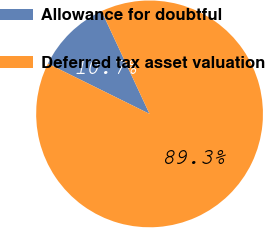Convert chart to OTSL. <chart><loc_0><loc_0><loc_500><loc_500><pie_chart><fcel>Allowance for doubtful<fcel>Deferred tax asset valuation<nl><fcel>10.73%<fcel>89.27%<nl></chart> 